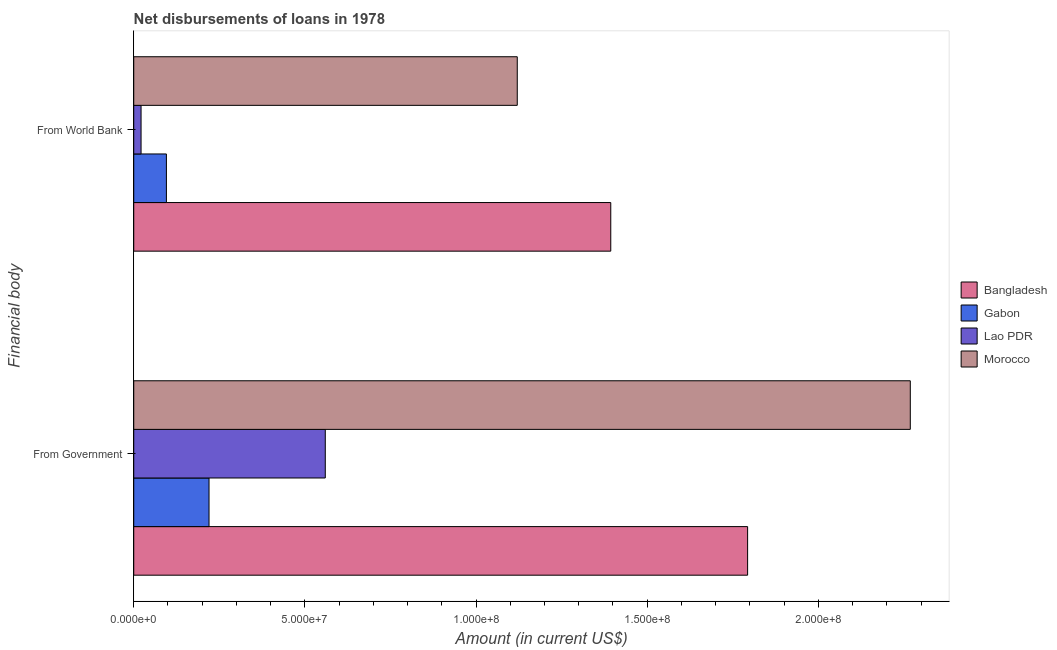How many different coloured bars are there?
Offer a very short reply. 4. How many groups of bars are there?
Keep it short and to the point. 2. How many bars are there on the 2nd tick from the top?
Give a very brief answer. 4. How many bars are there on the 2nd tick from the bottom?
Your response must be concise. 4. What is the label of the 1st group of bars from the top?
Ensure brevity in your answer.  From World Bank. What is the net disbursements of loan from world bank in Lao PDR?
Offer a terse response. 2.14e+06. Across all countries, what is the maximum net disbursements of loan from government?
Provide a short and direct response. 2.27e+08. Across all countries, what is the minimum net disbursements of loan from government?
Give a very brief answer. 2.20e+07. In which country was the net disbursements of loan from government maximum?
Keep it short and to the point. Morocco. In which country was the net disbursements of loan from government minimum?
Make the answer very short. Gabon. What is the total net disbursements of loan from world bank in the graph?
Your response must be concise. 2.63e+08. What is the difference between the net disbursements of loan from government in Bangladesh and that in Morocco?
Your response must be concise. -4.75e+07. What is the difference between the net disbursements of loan from world bank in Gabon and the net disbursements of loan from government in Morocco?
Offer a terse response. -2.17e+08. What is the average net disbursements of loan from government per country?
Your answer should be very brief. 1.21e+08. What is the difference between the net disbursements of loan from world bank and net disbursements of loan from government in Bangladesh?
Your answer should be very brief. -4.00e+07. What is the ratio of the net disbursements of loan from government in Morocco to that in Gabon?
Ensure brevity in your answer.  10.31. In how many countries, is the net disbursements of loan from government greater than the average net disbursements of loan from government taken over all countries?
Your answer should be compact. 2. What does the 3rd bar from the top in From World Bank represents?
Ensure brevity in your answer.  Gabon. What does the 1st bar from the bottom in From World Bank represents?
Make the answer very short. Bangladesh. How many bars are there?
Provide a succinct answer. 8. Are all the bars in the graph horizontal?
Offer a very short reply. Yes. How many countries are there in the graph?
Provide a short and direct response. 4. Does the graph contain any zero values?
Give a very brief answer. No. What is the title of the graph?
Offer a terse response. Net disbursements of loans in 1978. Does "Namibia" appear as one of the legend labels in the graph?
Your answer should be compact. No. What is the label or title of the Y-axis?
Offer a very short reply. Financial body. What is the Amount (in current US$) of Bangladesh in From Government?
Make the answer very short. 1.79e+08. What is the Amount (in current US$) in Gabon in From Government?
Offer a terse response. 2.20e+07. What is the Amount (in current US$) of Lao PDR in From Government?
Make the answer very short. 5.60e+07. What is the Amount (in current US$) of Morocco in From Government?
Give a very brief answer. 2.27e+08. What is the Amount (in current US$) in Bangladesh in From World Bank?
Your answer should be very brief. 1.39e+08. What is the Amount (in current US$) of Gabon in From World Bank?
Give a very brief answer. 9.54e+06. What is the Amount (in current US$) of Lao PDR in From World Bank?
Make the answer very short. 2.14e+06. What is the Amount (in current US$) of Morocco in From World Bank?
Make the answer very short. 1.12e+08. Across all Financial body, what is the maximum Amount (in current US$) in Bangladesh?
Your answer should be compact. 1.79e+08. Across all Financial body, what is the maximum Amount (in current US$) in Gabon?
Provide a short and direct response. 2.20e+07. Across all Financial body, what is the maximum Amount (in current US$) of Lao PDR?
Offer a very short reply. 5.60e+07. Across all Financial body, what is the maximum Amount (in current US$) in Morocco?
Your answer should be compact. 2.27e+08. Across all Financial body, what is the minimum Amount (in current US$) in Bangladesh?
Give a very brief answer. 1.39e+08. Across all Financial body, what is the minimum Amount (in current US$) of Gabon?
Your response must be concise. 9.54e+06. Across all Financial body, what is the minimum Amount (in current US$) of Lao PDR?
Keep it short and to the point. 2.14e+06. Across all Financial body, what is the minimum Amount (in current US$) of Morocco?
Your answer should be very brief. 1.12e+08. What is the total Amount (in current US$) in Bangladesh in the graph?
Your answer should be very brief. 3.19e+08. What is the total Amount (in current US$) of Gabon in the graph?
Ensure brevity in your answer.  3.15e+07. What is the total Amount (in current US$) of Lao PDR in the graph?
Your response must be concise. 5.81e+07. What is the total Amount (in current US$) of Morocco in the graph?
Provide a succinct answer. 3.39e+08. What is the difference between the Amount (in current US$) of Bangladesh in From Government and that in From World Bank?
Ensure brevity in your answer.  4.00e+07. What is the difference between the Amount (in current US$) of Gabon in From Government and that in From World Bank?
Offer a very short reply. 1.24e+07. What is the difference between the Amount (in current US$) of Lao PDR in From Government and that in From World Bank?
Your response must be concise. 5.38e+07. What is the difference between the Amount (in current US$) of Morocco in From Government and that in From World Bank?
Keep it short and to the point. 1.15e+08. What is the difference between the Amount (in current US$) of Bangladesh in From Government and the Amount (in current US$) of Gabon in From World Bank?
Give a very brief answer. 1.70e+08. What is the difference between the Amount (in current US$) of Bangladesh in From Government and the Amount (in current US$) of Lao PDR in From World Bank?
Keep it short and to the point. 1.77e+08. What is the difference between the Amount (in current US$) of Bangladesh in From Government and the Amount (in current US$) of Morocco in From World Bank?
Keep it short and to the point. 6.73e+07. What is the difference between the Amount (in current US$) in Gabon in From Government and the Amount (in current US$) in Lao PDR in From World Bank?
Provide a succinct answer. 1.99e+07. What is the difference between the Amount (in current US$) in Gabon in From Government and the Amount (in current US$) in Morocco in From World Bank?
Your response must be concise. -9.00e+07. What is the difference between the Amount (in current US$) in Lao PDR in From Government and the Amount (in current US$) in Morocco in From World Bank?
Offer a terse response. -5.61e+07. What is the average Amount (in current US$) in Bangladesh per Financial body?
Your answer should be very brief. 1.59e+08. What is the average Amount (in current US$) in Gabon per Financial body?
Ensure brevity in your answer.  1.58e+07. What is the average Amount (in current US$) of Lao PDR per Financial body?
Provide a short and direct response. 2.90e+07. What is the average Amount (in current US$) of Morocco per Financial body?
Provide a succinct answer. 1.69e+08. What is the difference between the Amount (in current US$) in Bangladesh and Amount (in current US$) in Gabon in From Government?
Give a very brief answer. 1.57e+08. What is the difference between the Amount (in current US$) in Bangladesh and Amount (in current US$) in Lao PDR in From Government?
Make the answer very short. 1.23e+08. What is the difference between the Amount (in current US$) in Bangladesh and Amount (in current US$) in Morocco in From Government?
Offer a very short reply. -4.75e+07. What is the difference between the Amount (in current US$) of Gabon and Amount (in current US$) of Lao PDR in From Government?
Your response must be concise. -3.40e+07. What is the difference between the Amount (in current US$) in Gabon and Amount (in current US$) in Morocco in From Government?
Your response must be concise. -2.05e+08. What is the difference between the Amount (in current US$) of Lao PDR and Amount (in current US$) of Morocco in From Government?
Make the answer very short. -1.71e+08. What is the difference between the Amount (in current US$) in Bangladesh and Amount (in current US$) in Gabon in From World Bank?
Make the answer very short. 1.30e+08. What is the difference between the Amount (in current US$) in Bangladesh and Amount (in current US$) in Lao PDR in From World Bank?
Make the answer very short. 1.37e+08. What is the difference between the Amount (in current US$) of Bangladesh and Amount (in current US$) of Morocco in From World Bank?
Keep it short and to the point. 2.73e+07. What is the difference between the Amount (in current US$) of Gabon and Amount (in current US$) of Lao PDR in From World Bank?
Your answer should be very brief. 7.41e+06. What is the difference between the Amount (in current US$) in Gabon and Amount (in current US$) in Morocco in From World Bank?
Give a very brief answer. -1.02e+08. What is the difference between the Amount (in current US$) in Lao PDR and Amount (in current US$) in Morocco in From World Bank?
Your answer should be very brief. -1.10e+08. What is the ratio of the Amount (in current US$) in Bangladesh in From Government to that in From World Bank?
Offer a very short reply. 1.29. What is the ratio of the Amount (in current US$) of Gabon in From Government to that in From World Bank?
Offer a very short reply. 2.3. What is the ratio of the Amount (in current US$) in Lao PDR in From Government to that in From World Bank?
Provide a succinct answer. 26.18. What is the ratio of the Amount (in current US$) of Morocco in From Government to that in From World Bank?
Give a very brief answer. 2.02. What is the difference between the highest and the second highest Amount (in current US$) in Bangladesh?
Make the answer very short. 4.00e+07. What is the difference between the highest and the second highest Amount (in current US$) in Gabon?
Your answer should be very brief. 1.24e+07. What is the difference between the highest and the second highest Amount (in current US$) of Lao PDR?
Give a very brief answer. 5.38e+07. What is the difference between the highest and the second highest Amount (in current US$) in Morocco?
Ensure brevity in your answer.  1.15e+08. What is the difference between the highest and the lowest Amount (in current US$) of Bangladesh?
Ensure brevity in your answer.  4.00e+07. What is the difference between the highest and the lowest Amount (in current US$) in Gabon?
Your response must be concise. 1.24e+07. What is the difference between the highest and the lowest Amount (in current US$) in Lao PDR?
Offer a terse response. 5.38e+07. What is the difference between the highest and the lowest Amount (in current US$) in Morocco?
Give a very brief answer. 1.15e+08. 